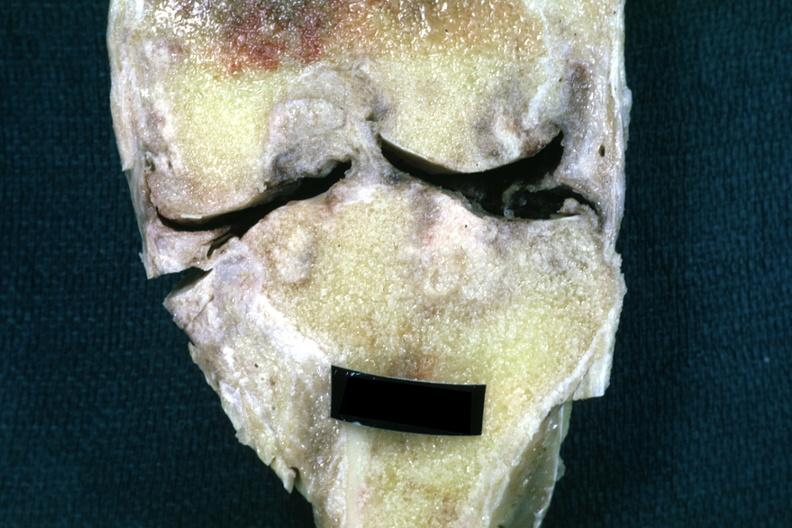what does this image show?
Answer the question using a single word or phrase. Fixed tissue frontal section of joint with obvious cartilage loss and subsynovial fibrosis 